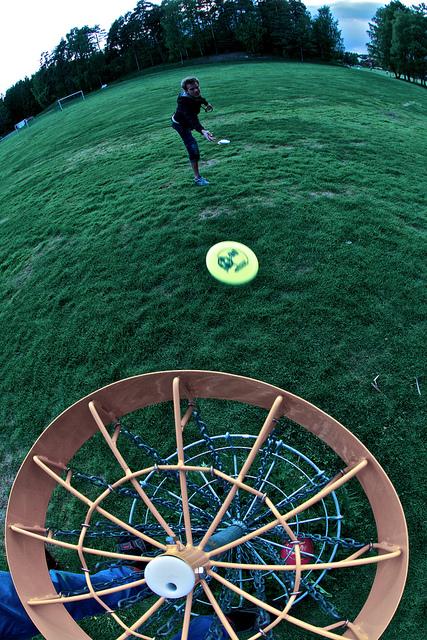What game is being played?
Write a very short answer. Frisbee. What color is the frisbee before the goal?
Write a very short answer. Green. Is the lens on this camera normal?
Be succinct. No. 